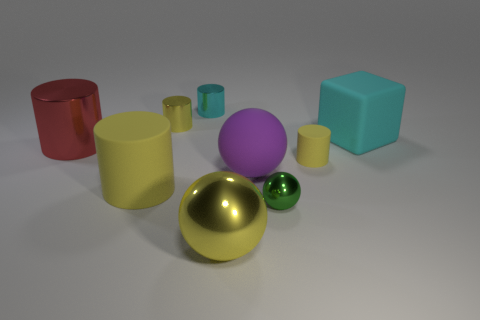What is the shape of the yellow rubber thing to the right of the yellow metallic object that is behind the small cylinder in front of the yellow metallic cylinder? The yellow rubber item to the right of the yellow metallic object appears to be a cylinder, similar to the nearby objects, but with a distinguishing matte finish and a rubber texture, setting it apart from the metallic sheen seen on the object beside it. 